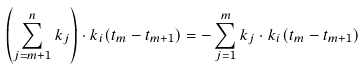<formula> <loc_0><loc_0><loc_500><loc_500>\left ( \sum _ { j = m + 1 } ^ { n } k _ { j } \right ) \cdot k _ { i } ( t _ { m } - t _ { m + 1 } ) = - \sum _ { j = 1 } ^ { m } k _ { j } \cdot k _ { i } ( t _ { m } - t _ { m + 1 } )</formula> 